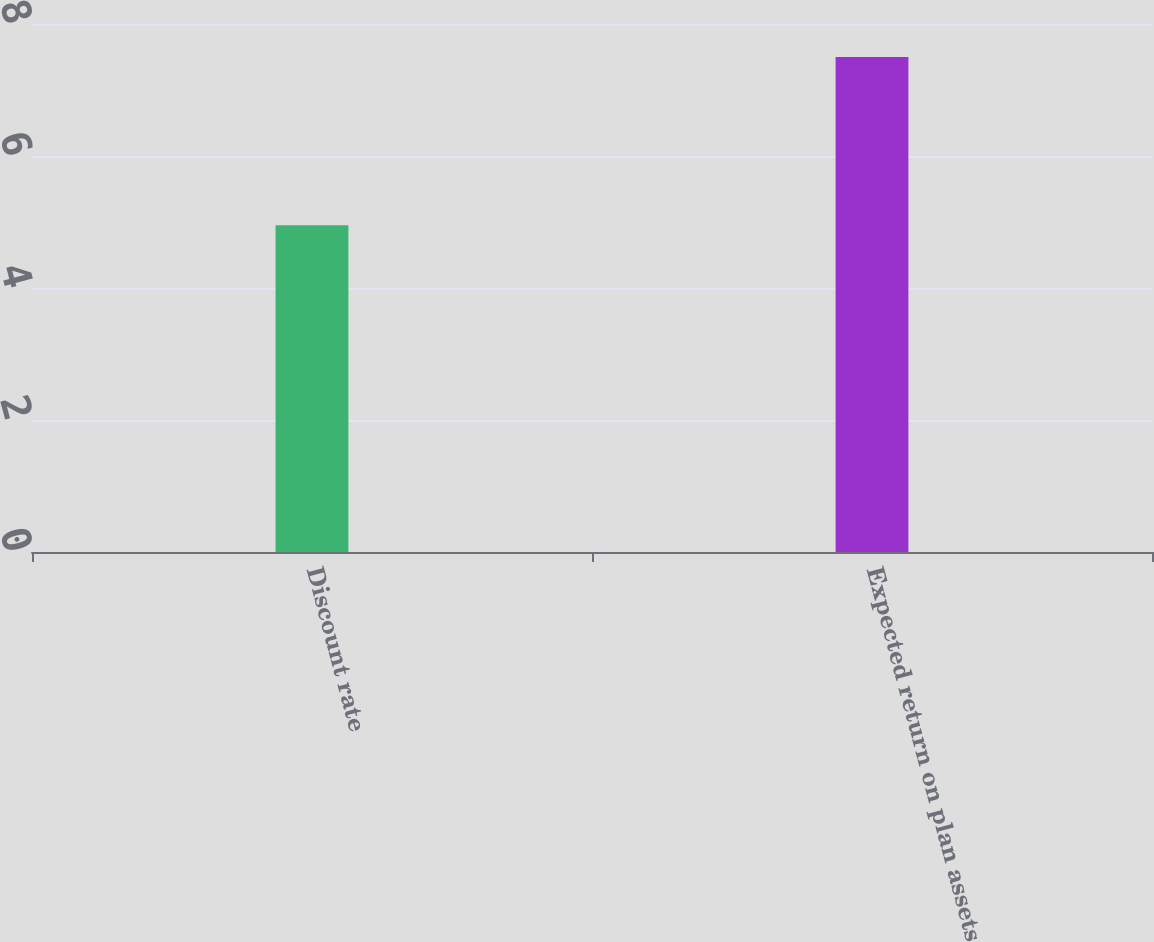Convert chart to OTSL. <chart><loc_0><loc_0><loc_500><loc_500><bar_chart><fcel>Discount rate<fcel>Expected return on plan assets<nl><fcel>4.95<fcel>7.5<nl></chart> 